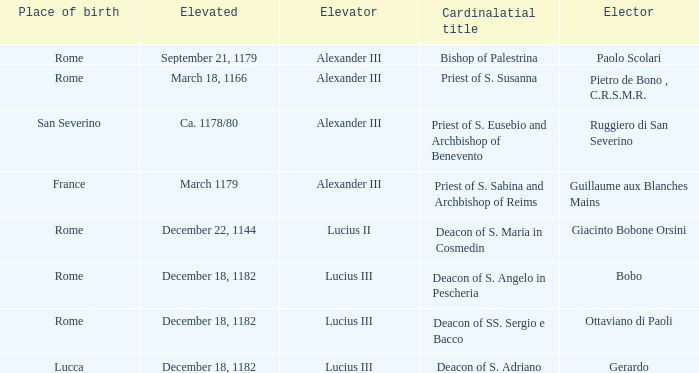Parse the full table. {'header': ['Place of birth', 'Elevated', 'Elevator', 'Cardinalatial title', 'Elector'], 'rows': [['Rome', 'September 21, 1179', 'Alexander III', 'Bishop of Palestrina', 'Paolo Scolari'], ['Rome', 'March 18, 1166', 'Alexander III', 'Priest of S. Susanna', 'Pietro de Bono , C.R.S.M.R.'], ['San Severino', 'Ca. 1178/80', 'Alexander III', 'Priest of S. Eusebio and Archbishop of Benevento', 'Ruggiero di San Severino'], ['France', 'March 1179', 'Alexander III', 'Priest of S. Sabina and Archbishop of Reims', 'Guillaume aux Blanches Mains'], ['Rome', 'December 22, 1144', 'Lucius II', 'Deacon of S. Maria in Cosmedin', 'Giacinto Bobone Orsini'], ['Rome', 'December 18, 1182', 'Lucius III', 'Deacon of S. Angelo in Pescheria', 'Bobo'], ['Rome', 'December 18, 1182', 'Lucius III', 'Deacon of SS. Sergio e Bacco', 'Ottaviano di Paoli'], ['Lucca', 'December 18, 1182', 'Lucius III', 'Deacon of S. Adriano', 'Gerardo']]} What Elector has an Elevator of Alexander III and a Cardinalatial title of Bishop of Palestrina? Paolo Scolari. 